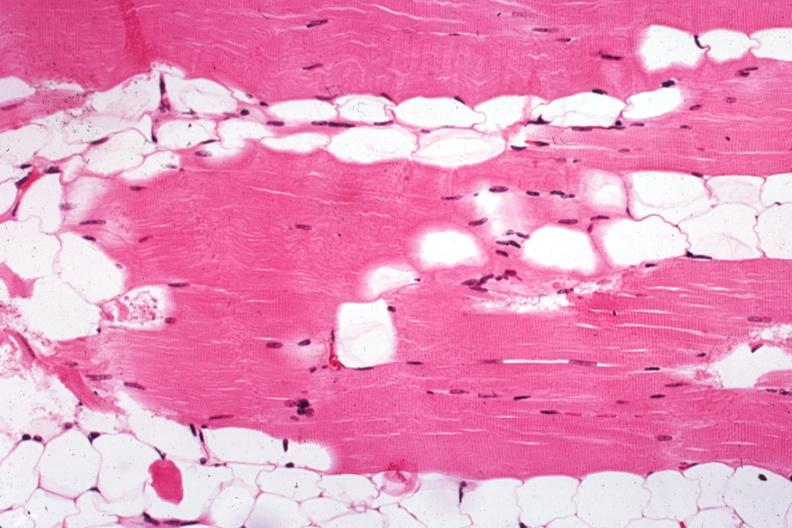s soft tissue present?
Answer the question using a single word or phrase. Yes 